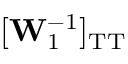Convert formula to latex. <formula><loc_0><loc_0><loc_500><loc_500>[ W _ { 1 } ^ { - 1 } ] _ { T T }</formula> 